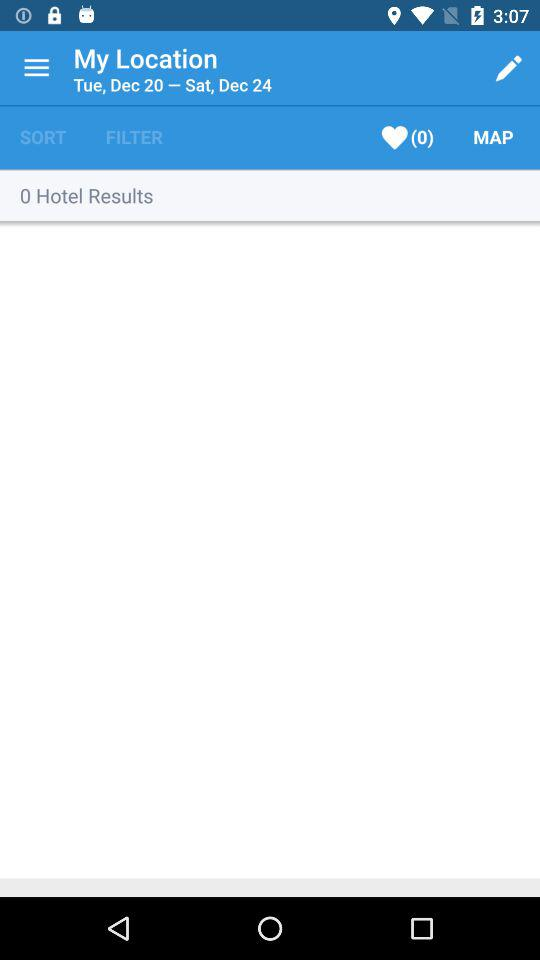What is the check-in date? The check-in date is Tuesday, December 20. 